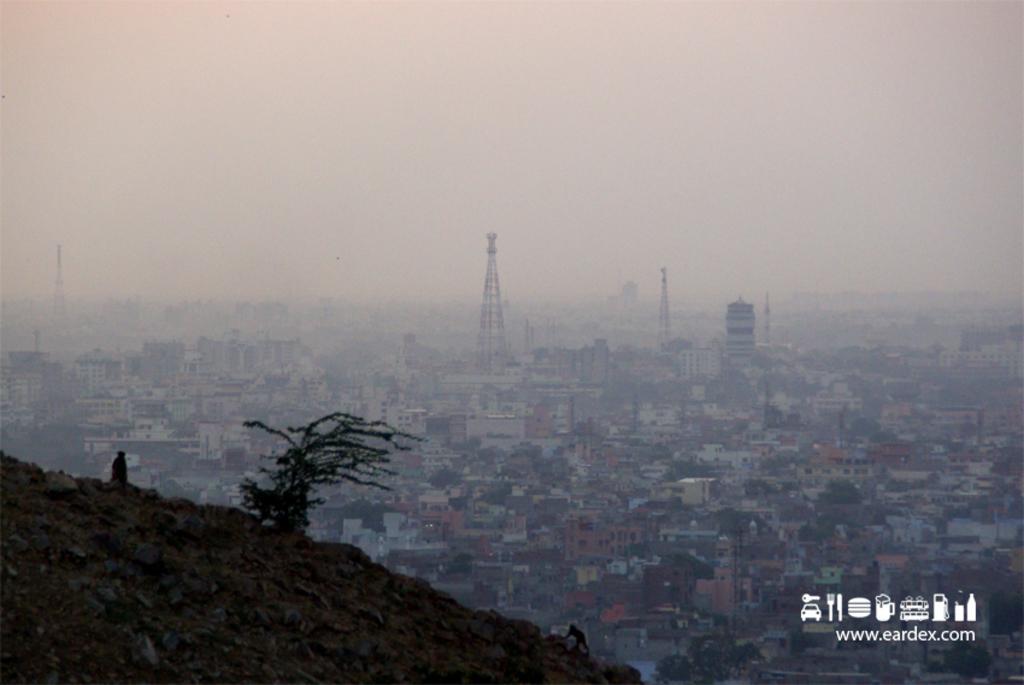Describe this image in one or two sentences. In this image I can see the plant and two animals. In the background I can see many buildings, trees and the sky. 